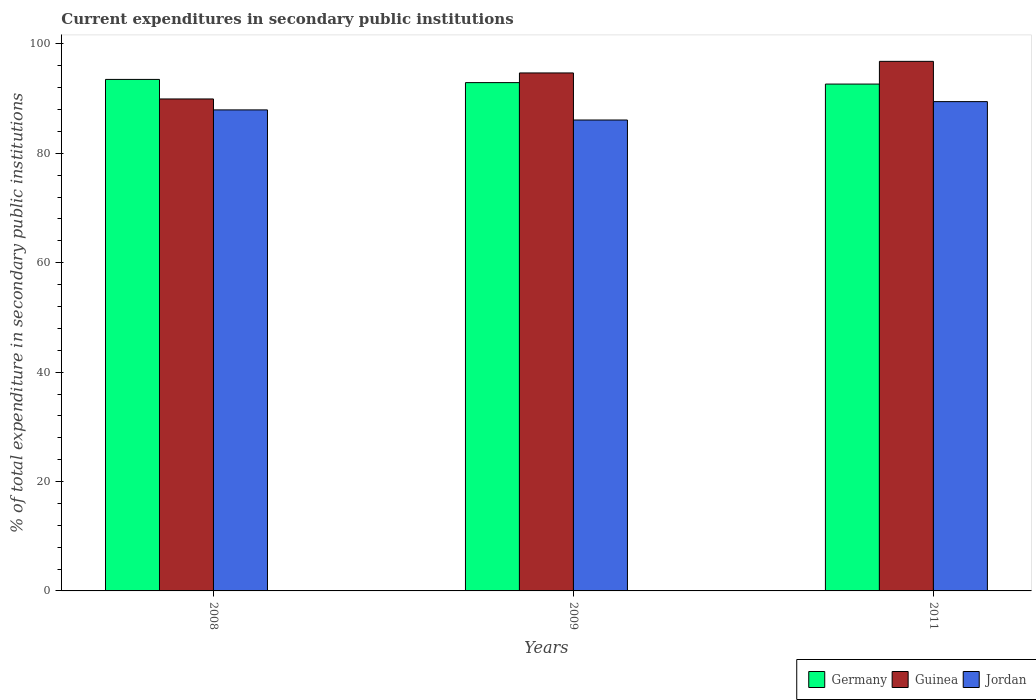How many different coloured bars are there?
Keep it short and to the point. 3. How many groups of bars are there?
Offer a very short reply. 3. Are the number of bars on each tick of the X-axis equal?
Keep it short and to the point. Yes. How many bars are there on the 1st tick from the left?
Keep it short and to the point. 3. What is the label of the 3rd group of bars from the left?
Provide a succinct answer. 2011. What is the current expenditures in secondary public institutions in Germany in 2008?
Keep it short and to the point. 93.51. Across all years, what is the maximum current expenditures in secondary public institutions in Guinea?
Keep it short and to the point. 96.81. Across all years, what is the minimum current expenditures in secondary public institutions in Guinea?
Your response must be concise. 89.94. What is the total current expenditures in secondary public institutions in Guinea in the graph?
Provide a short and direct response. 281.45. What is the difference between the current expenditures in secondary public institutions in Guinea in 2008 and that in 2009?
Keep it short and to the point. -4.76. What is the difference between the current expenditures in secondary public institutions in Guinea in 2008 and the current expenditures in secondary public institutions in Germany in 2011?
Make the answer very short. -2.72. What is the average current expenditures in secondary public institutions in Guinea per year?
Ensure brevity in your answer.  93.82. In the year 2011, what is the difference between the current expenditures in secondary public institutions in Germany and current expenditures in secondary public institutions in Jordan?
Offer a very short reply. 3.21. What is the ratio of the current expenditures in secondary public institutions in Guinea in 2009 to that in 2011?
Give a very brief answer. 0.98. Is the difference between the current expenditures in secondary public institutions in Germany in 2008 and 2011 greater than the difference between the current expenditures in secondary public institutions in Jordan in 2008 and 2011?
Offer a terse response. Yes. What is the difference between the highest and the second highest current expenditures in secondary public institutions in Jordan?
Offer a terse response. 1.51. What is the difference between the highest and the lowest current expenditures in secondary public institutions in Jordan?
Your response must be concise. 3.36. In how many years, is the current expenditures in secondary public institutions in Jordan greater than the average current expenditures in secondary public institutions in Jordan taken over all years?
Offer a terse response. 2. Is the sum of the current expenditures in secondary public institutions in Guinea in 2008 and 2011 greater than the maximum current expenditures in secondary public institutions in Jordan across all years?
Make the answer very short. Yes. What does the 1st bar from the right in 2009 represents?
Your answer should be very brief. Jordan. Is it the case that in every year, the sum of the current expenditures in secondary public institutions in Jordan and current expenditures in secondary public institutions in Guinea is greater than the current expenditures in secondary public institutions in Germany?
Offer a terse response. Yes. How many bars are there?
Your answer should be compact. 9. How many years are there in the graph?
Offer a very short reply. 3. Does the graph contain grids?
Keep it short and to the point. No. Where does the legend appear in the graph?
Ensure brevity in your answer.  Bottom right. How many legend labels are there?
Give a very brief answer. 3. How are the legend labels stacked?
Offer a terse response. Horizontal. What is the title of the graph?
Offer a very short reply. Current expenditures in secondary public institutions. What is the label or title of the X-axis?
Ensure brevity in your answer.  Years. What is the label or title of the Y-axis?
Make the answer very short. % of total expenditure in secondary public institutions. What is the % of total expenditure in secondary public institutions in Germany in 2008?
Offer a very short reply. 93.51. What is the % of total expenditure in secondary public institutions of Guinea in 2008?
Your answer should be very brief. 89.94. What is the % of total expenditure in secondary public institutions in Jordan in 2008?
Offer a terse response. 87.94. What is the % of total expenditure in secondary public institutions in Germany in 2009?
Offer a very short reply. 92.92. What is the % of total expenditure in secondary public institutions in Guinea in 2009?
Provide a short and direct response. 94.69. What is the % of total expenditure in secondary public institutions in Jordan in 2009?
Provide a succinct answer. 86.09. What is the % of total expenditure in secondary public institutions in Germany in 2011?
Provide a succinct answer. 92.66. What is the % of total expenditure in secondary public institutions in Guinea in 2011?
Offer a terse response. 96.81. What is the % of total expenditure in secondary public institutions in Jordan in 2011?
Keep it short and to the point. 89.45. Across all years, what is the maximum % of total expenditure in secondary public institutions in Germany?
Ensure brevity in your answer.  93.51. Across all years, what is the maximum % of total expenditure in secondary public institutions in Guinea?
Your answer should be very brief. 96.81. Across all years, what is the maximum % of total expenditure in secondary public institutions of Jordan?
Your response must be concise. 89.45. Across all years, what is the minimum % of total expenditure in secondary public institutions in Germany?
Ensure brevity in your answer.  92.66. Across all years, what is the minimum % of total expenditure in secondary public institutions of Guinea?
Offer a very short reply. 89.94. Across all years, what is the minimum % of total expenditure in secondary public institutions of Jordan?
Ensure brevity in your answer.  86.09. What is the total % of total expenditure in secondary public institutions in Germany in the graph?
Keep it short and to the point. 279.1. What is the total % of total expenditure in secondary public institutions of Guinea in the graph?
Your answer should be very brief. 281.45. What is the total % of total expenditure in secondary public institutions in Jordan in the graph?
Offer a very short reply. 263.48. What is the difference between the % of total expenditure in secondary public institutions of Germany in 2008 and that in 2009?
Ensure brevity in your answer.  0.59. What is the difference between the % of total expenditure in secondary public institutions of Guinea in 2008 and that in 2009?
Provide a succinct answer. -4.76. What is the difference between the % of total expenditure in secondary public institutions of Jordan in 2008 and that in 2009?
Offer a very short reply. 1.85. What is the difference between the % of total expenditure in secondary public institutions of Germany in 2008 and that in 2011?
Make the answer very short. 0.85. What is the difference between the % of total expenditure in secondary public institutions of Guinea in 2008 and that in 2011?
Provide a short and direct response. -6.88. What is the difference between the % of total expenditure in secondary public institutions in Jordan in 2008 and that in 2011?
Your response must be concise. -1.51. What is the difference between the % of total expenditure in secondary public institutions of Germany in 2009 and that in 2011?
Offer a terse response. 0.26. What is the difference between the % of total expenditure in secondary public institutions in Guinea in 2009 and that in 2011?
Your answer should be very brief. -2.12. What is the difference between the % of total expenditure in secondary public institutions of Jordan in 2009 and that in 2011?
Your answer should be compact. -3.36. What is the difference between the % of total expenditure in secondary public institutions in Germany in 2008 and the % of total expenditure in secondary public institutions in Guinea in 2009?
Your answer should be very brief. -1.18. What is the difference between the % of total expenditure in secondary public institutions in Germany in 2008 and the % of total expenditure in secondary public institutions in Jordan in 2009?
Your answer should be very brief. 7.42. What is the difference between the % of total expenditure in secondary public institutions of Guinea in 2008 and the % of total expenditure in secondary public institutions of Jordan in 2009?
Give a very brief answer. 3.85. What is the difference between the % of total expenditure in secondary public institutions in Germany in 2008 and the % of total expenditure in secondary public institutions in Guinea in 2011?
Your answer should be compact. -3.3. What is the difference between the % of total expenditure in secondary public institutions of Germany in 2008 and the % of total expenditure in secondary public institutions of Jordan in 2011?
Your answer should be very brief. 4.06. What is the difference between the % of total expenditure in secondary public institutions in Guinea in 2008 and the % of total expenditure in secondary public institutions in Jordan in 2011?
Provide a succinct answer. 0.49. What is the difference between the % of total expenditure in secondary public institutions of Germany in 2009 and the % of total expenditure in secondary public institutions of Guinea in 2011?
Your answer should be compact. -3.89. What is the difference between the % of total expenditure in secondary public institutions of Germany in 2009 and the % of total expenditure in secondary public institutions of Jordan in 2011?
Make the answer very short. 3.47. What is the difference between the % of total expenditure in secondary public institutions of Guinea in 2009 and the % of total expenditure in secondary public institutions of Jordan in 2011?
Ensure brevity in your answer.  5.24. What is the average % of total expenditure in secondary public institutions in Germany per year?
Provide a succinct answer. 93.03. What is the average % of total expenditure in secondary public institutions in Guinea per year?
Provide a short and direct response. 93.82. What is the average % of total expenditure in secondary public institutions of Jordan per year?
Provide a short and direct response. 87.83. In the year 2008, what is the difference between the % of total expenditure in secondary public institutions in Germany and % of total expenditure in secondary public institutions in Guinea?
Keep it short and to the point. 3.57. In the year 2008, what is the difference between the % of total expenditure in secondary public institutions in Germany and % of total expenditure in secondary public institutions in Jordan?
Provide a short and direct response. 5.57. In the year 2008, what is the difference between the % of total expenditure in secondary public institutions in Guinea and % of total expenditure in secondary public institutions in Jordan?
Ensure brevity in your answer.  2. In the year 2009, what is the difference between the % of total expenditure in secondary public institutions in Germany and % of total expenditure in secondary public institutions in Guinea?
Ensure brevity in your answer.  -1.77. In the year 2009, what is the difference between the % of total expenditure in secondary public institutions in Germany and % of total expenditure in secondary public institutions in Jordan?
Your answer should be very brief. 6.83. In the year 2009, what is the difference between the % of total expenditure in secondary public institutions of Guinea and % of total expenditure in secondary public institutions of Jordan?
Your answer should be very brief. 8.6. In the year 2011, what is the difference between the % of total expenditure in secondary public institutions of Germany and % of total expenditure in secondary public institutions of Guinea?
Keep it short and to the point. -4.15. In the year 2011, what is the difference between the % of total expenditure in secondary public institutions in Germany and % of total expenditure in secondary public institutions in Jordan?
Give a very brief answer. 3.21. In the year 2011, what is the difference between the % of total expenditure in secondary public institutions in Guinea and % of total expenditure in secondary public institutions in Jordan?
Offer a very short reply. 7.36. What is the ratio of the % of total expenditure in secondary public institutions in Guinea in 2008 to that in 2009?
Offer a terse response. 0.95. What is the ratio of the % of total expenditure in secondary public institutions in Jordan in 2008 to that in 2009?
Your answer should be compact. 1.02. What is the ratio of the % of total expenditure in secondary public institutions in Germany in 2008 to that in 2011?
Offer a very short reply. 1.01. What is the ratio of the % of total expenditure in secondary public institutions of Guinea in 2008 to that in 2011?
Your response must be concise. 0.93. What is the ratio of the % of total expenditure in secondary public institutions in Jordan in 2008 to that in 2011?
Offer a terse response. 0.98. What is the ratio of the % of total expenditure in secondary public institutions of Guinea in 2009 to that in 2011?
Your response must be concise. 0.98. What is the ratio of the % of total expenditure in secondary public institutions of Jordan in 2009 to that in 2011?
Provide a succinct answer. 0.96. What is the difference between the highest and the second highest % of total expenditure in secondary public institutions of Germany?
Offer a very short reply. 0.59. What is the difference between the highest and the second highest % of total expenditure in secondary public institutions in Guinea?
Provide a short and direct response. 2.12. What is the difference between the highest and the second highest % of total expenditure in secondary public institutions of Jordan?
Provide a short and direct response. 1.51. What is the difference between the highest and the lowest % of total expenditure in secondary public institutions of Germany?
Give a very brief answer. 0.85. What is the difference between the highest and the lowest % of total expenditure in secondary public institutions of Guinea?
Give a very brief answer. 6.88. What is the difference between the highest and the lowest % of total expenditure in secondary public institutions in Jordan?
Provide a succinct answer. 3.36. 